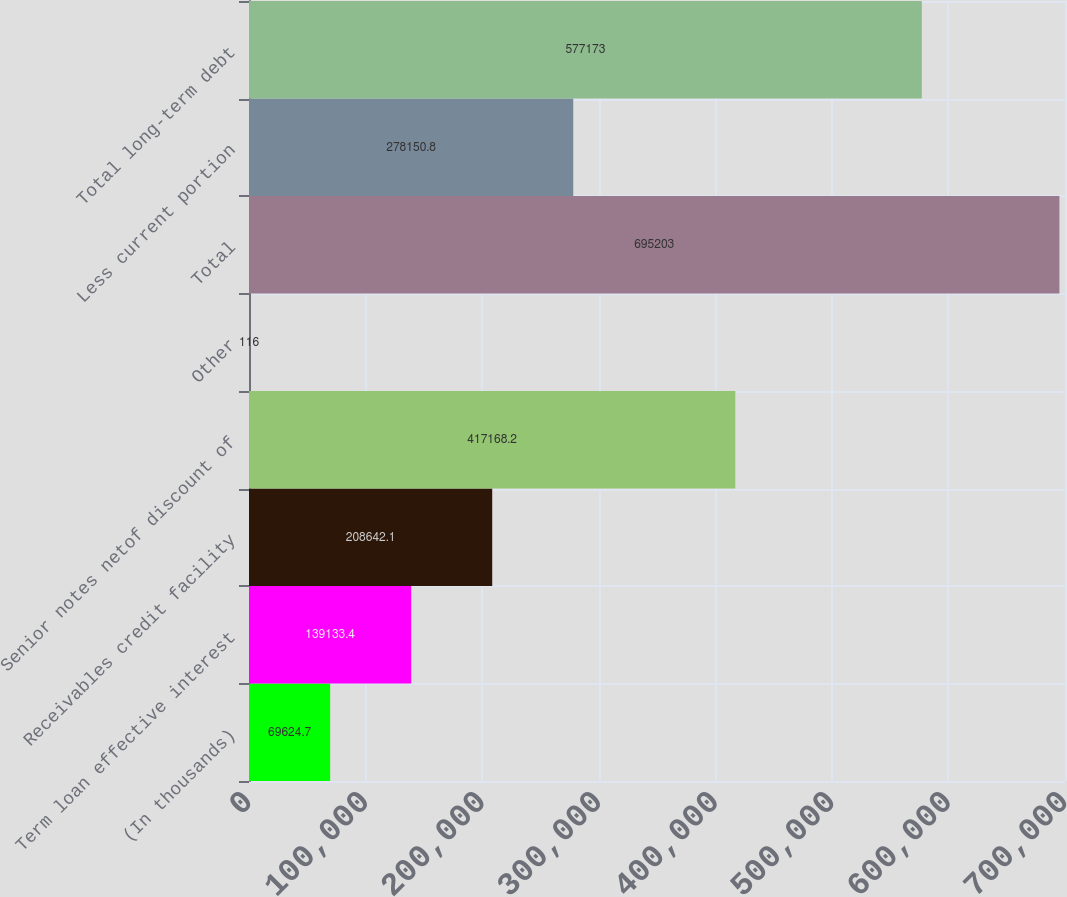Convert chart. <chart><loc_0><loc_0><loc_500><loc_500><bar_chart><fcel>(In thousands)<fcel>Term loan effective interest<fcel>Receivables credit facility<fcel>Senior notes netof discount of<fcel>Other<fcel>Total<fcel>Less current portion<fcel>Total long-term debt<nl><fcel>69624.7<fcel>139133<fcel>208642<fcel>417168<fcel>116<fcel>695203<fcel>278151<fcel>577173<nl></chart> 